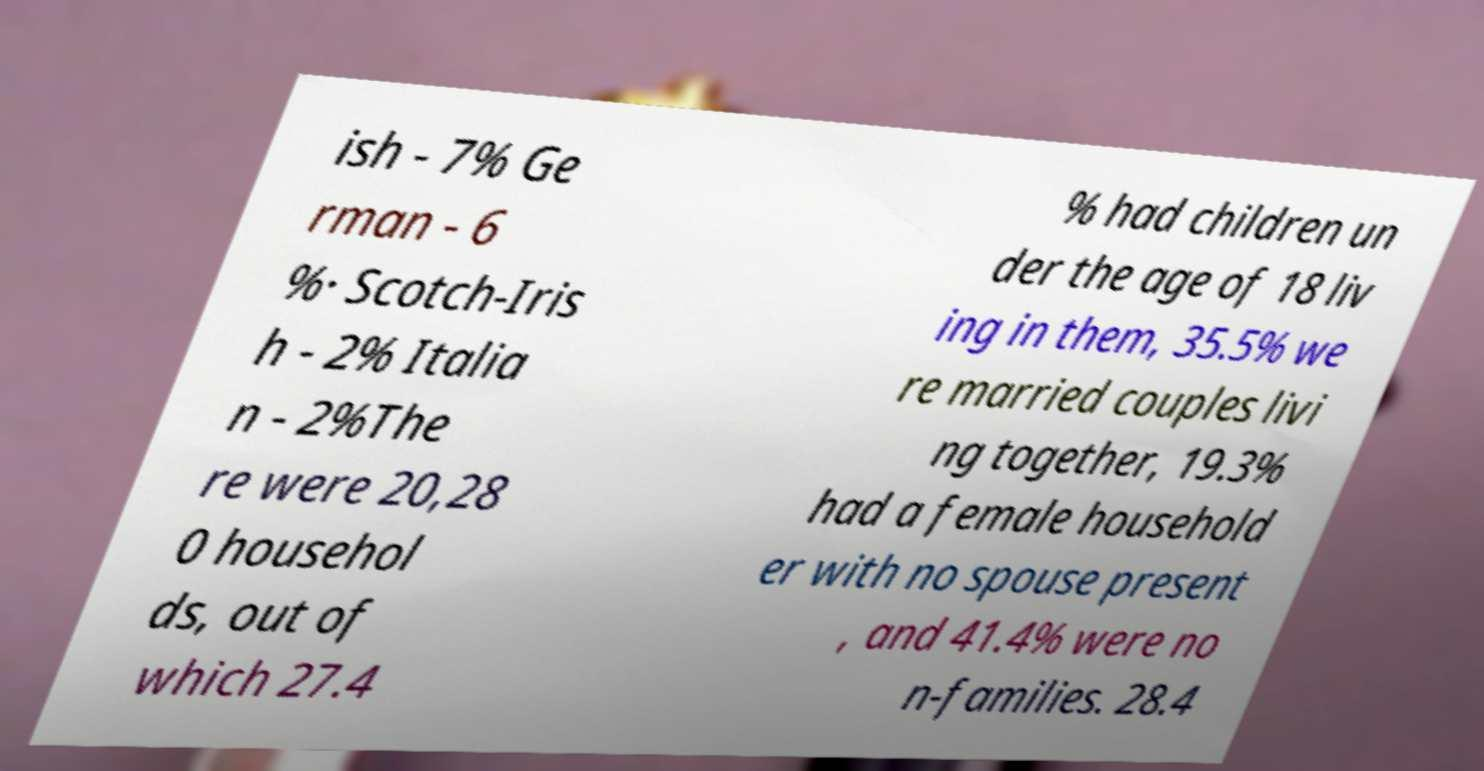Could you assist in decoding the text presented in this image and type it out clearly? ish - 7% Ge rman - 6 %· Scotch-Iris h - 2% Italia n - 2%The re were 20,28 0 househol ds, out of which 27.4 % had children un der the age of 18 liv ing in them, 35.5% we re married couples livi ng together, 19.3% had a female household er with no spouse present , and 41.4% were no n-families. 28.4 